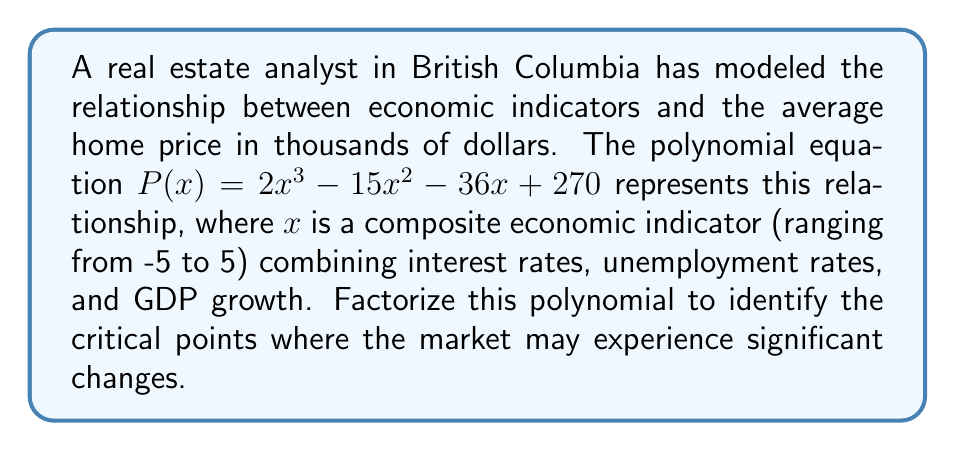Solve this math problem. To factorize the polynomial $P(x) = 2x^3 - 15x^2 - 36x + 270$, we'll follow these steps:

1) First, let's check if there's a common factor:
   There's no common factor for all terms, so we proceed to the next step.

2) We'll use the rational root theorem to find potential roots. The possible rational roots are the factors of the constant term (270) divided by the factors of the leading coefficient (2):
   $$\pm 1, \pm 2, \pm 3, \pm 5, \pm 6, \pm 9, \pm 10, \pm 15, \pm 18, \pm 27, \pm 30, \pm 45, \pm 54, \pm 90, \pm 135, \pm 270$$

3) Let's test these values using synthetic division. We find that 9 is a root:

   $$
   \begin{array}{r|r}
   2 & -15 & -36 & 270 \\
   & 18 & 27 & -81 \\
   \hline
   2 & 3 & -9 & 189
   \end{array}
   $$

4) So, $(x - 9)$ is a factor. We can now write:
   $P(x) = (x - 9)(2x^2 + 3x - 30)$

5) Now we need to factor the quadratic $2x^2 + 3x - 30$. We can use the quadratic formula or factoring by grouping. Let's use factoring by grouping:

   $2x^2 + 3x - 30 = (2x - 10)(x + 3)$

6) Therefore, our final factorization is:
   $P(x) = (x - 9)(2x - 10)(x + 3)$

This factorization reveals the roots of the polynomial, which are the critical points where the market may experience significant changes: $x = 9$, $x = 5$, and $x = -3$.
Answer: $P(x) = (x - 9)(2x - 10)(x + 3)$ 